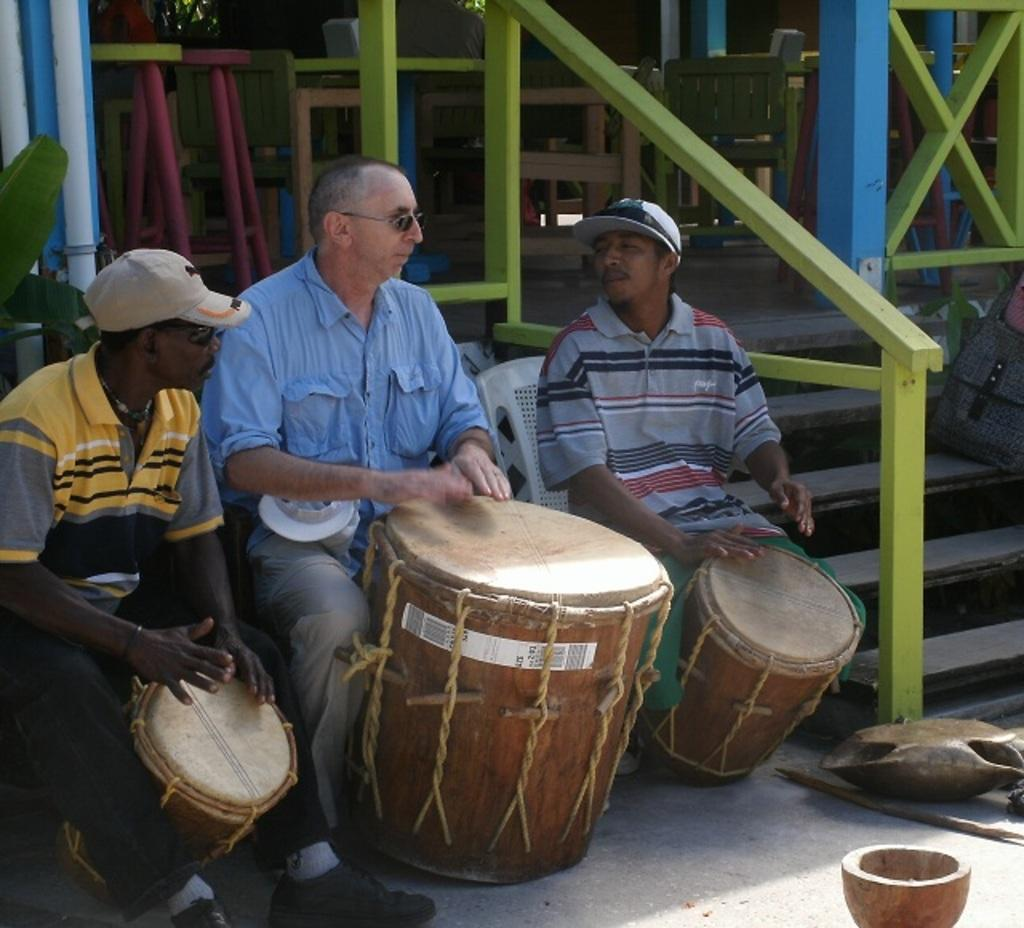What is happening in the foreground of the image? Three men are sitting and playing musical instruments. What can be seen in the background of the image? There are empty chairs and tables in the background. Are there any architectural features in the image? Yes, there are stairs in the image. Is there any vegetation present in the image? Yes, there is a plant in the image. What type of berry is being used as a drumstick by one of the musicians in the image? There are no berries or drumsticks present in the image; the musicians are playing musical instruments with their hands or other traditional methods. 